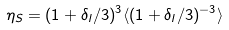Convert formula to latex. <formula><loc_0><loc_0><loc_500><loc_500>\eta _ { S } = ( 1 + \delta _ { l } / 3 ) ^ { 3 } \langle ( 1 + \delta _ { l } / 3 ) ^ { - 3 } \rangle</formula> 